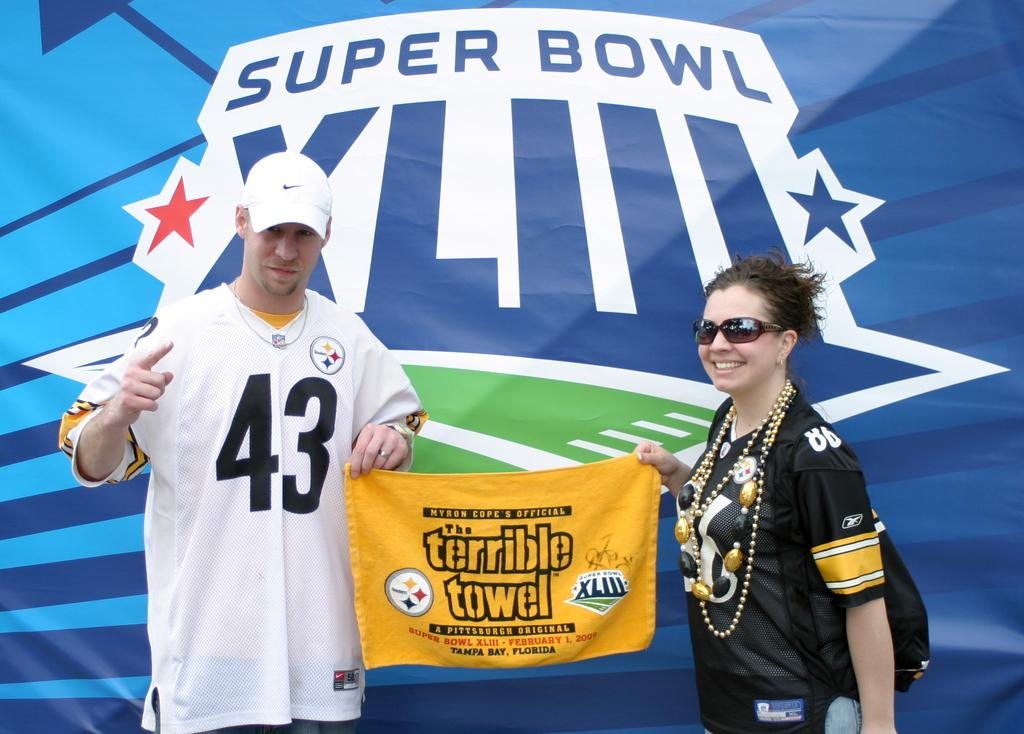How many people are in the image? There are two people in the image. What are the two people holding? The two people are holding a towel. Is there any text on the towel? Yes, there is a name written on the towel. What else can be seen in the image besides the people and the towel? There is a banner visible in the image. What type of school is visible in the image? There is no school present in the image. How does the boundary affect the interaction between the two people in the image? There is no boundary mentioned or visible in the image. 